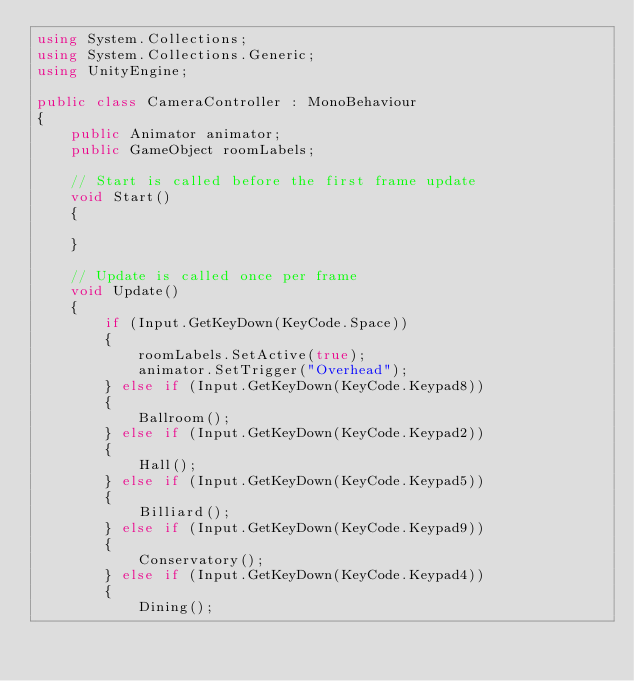<code> <loc_0><loc_0><loc_500><loc_500><_C#_>using System.Collections;
using System.Collections.Generic;
using UnityEngine;

public class CameraController : MonoBehaviour
{
    public Animator animator;
    public GameObject roomLabels;

    // Start is called before the first frame update
    void Start()
    {
        
    }

    // Update is called once per frame
    void Update()
    {
        if (Input.GetKeyDown(KeyCode.Space))
        {
            roomLabels.SetActive(true);
            animator.SetTrigger("Overhead");
        } else if (Input.GetKeyDown(KeyCode.Keypad8))
        {
            Ballroom();
        } else if (Input.GetKeyDown(KeyCode.Keypad2))
        {
            Hall();
        } else if (Input.GetKeyDown(KeyCode.Keypad5))
        {
            Billiard();
        } else if (Input.GetKeyDown(KeyCode.Keypad9))
        {
            Conservatory();
        } else if (Input.GetKeyDown(KeyCode.Keypad4))
        {
            Dining();</code> 